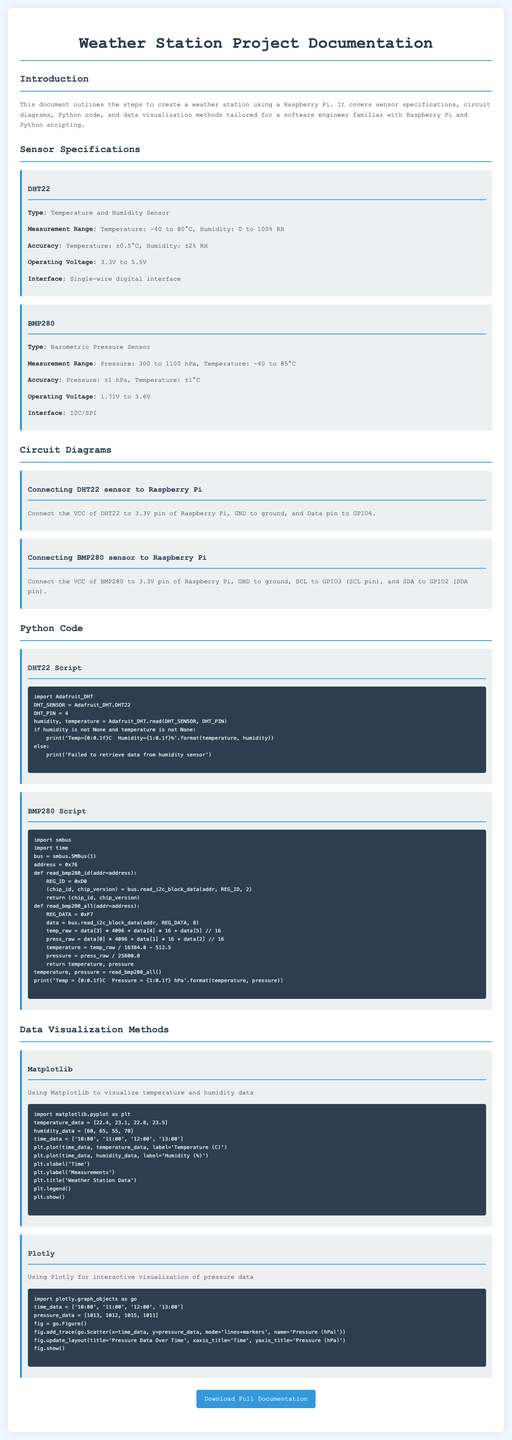What type of sensor is DHT22? The DHT22 is specified as a temperature and humidity sensor in the document.
Answer: Temperature and Humidity Sensor What is the measurement range for the BMP280 sensor? The measurement range for the BMP280 sensor includes pressure from 300 to 1100 hPa and temperature from -40 to 85°C.
Answer: 300 to 1100 hPa, -40 to 85°C Which GPIO pin is the DHT22 data pin connected to? The document specifies that the data pin of the DHT22 is connected to GPIO4 on the Raspberry Pi.
Answer: GPIO4 What is the accuracy of temperature measurement for the DHT22 sensor? The accuracy for temperature measurement specified in the document is ±0.5°C.
Answer: ±0.5°C Which Python library is used for the DHT22 script? The DHT22 script in the document uses the Adafruit_DHT library.
Answer: Adafruit_DHT How many data points are included in the temperature_data list provided for visualization? The temperature_data list in the visualization section includes four data points as shown in the example.
Answer: Four What is the operating voltage range for the BMP280 sensor? The document states that the BMP280 sensor operates within a voltage range of 1.71V to 3.6V.
Answer: 1.71V to 3.6V Which method is mentioned for visualizing pressure data? The document mentions using Plotly for interactive visualization of pressure data.
Answer: Plotly What is the purpose of the button labeled "Download Full Documentation"? The button allows users to download the full project documentation as indicated by its label in the document.
Answer: Download the full project documentation 